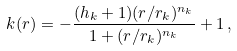Convert formula to latex. <formula><loc_0><loc_0><loc_500><loc_500>k ( r ) = - \frac { ( h _ { k } + 1 ) ( r / r _ { k } ) ^ { n _ { k } } } { 1 + ( r / r _ { k } ) ^ { n _ { k } } } + 1 \, ,</formula> 